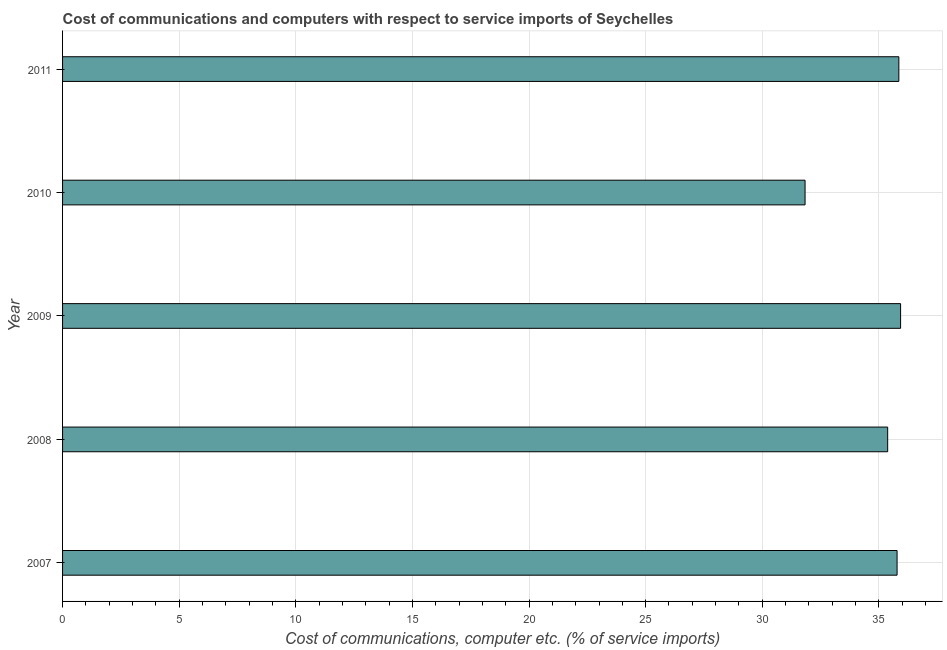Does the graph contain any zero values?
Your answer should be very brief. No. Does the graph contain grids?
Ensure brevity in your answer.  Yes. What is the title of the graph?
Provide a succinct answer. Cost of communications and computers with respect to service imports of Seychelles. What is the label or title of the X-axis?
Offer a terse response. Cost of communications, computer etc. (% of service imports). What is the cost of communications and computer in 2009?
Provide a short and direct response. 35.93. Across all years, what is the maximum cost of communications and computer?
Provide a short and direct response. 35.93. Across all years, what is the minimum cost of communications and computer?
Offer a very short reply. 31.83. In which year was the cost of communications and computer minimum?
Your answer should be compact. 2010. What is the sum of the cost of communications and computer?
Provide a succinct answer. 174.77. What is the difference between the cost of communications and computer in 2009 and 2011?
Provide a succinct answer. 0.07. What is the average cost of communications and computer per year?
Keep it short and to the point. 34.95. What is the median cost of communications and computer?
Ensure brevity in your answer.  35.78. What is the ratio of the cost of communications and computer in 2008 to that in 2009?
Provide a short and direct response. 0.98. Is the cost of communications and computer in 2008 less than that in 2011?
Make the answer very short. Yes. Is the difference between the cost of communications and computer in 2008 and 2010 greater than the difference between any two years?
Offer a very short reply. No. What is the difference between the highest and the second highest cost of communications and computer?
Make the answer very short. 0.07. In how many years, is the cost of communications and computer greater than the average cost of communications and computer taken over all years?
Your answer should be very brief. 4. How many bars are there?
Your response must be concise. 5. Are all the bars in the graph horizontal?
Give a very brief answer. Yes. How many years are there in the graph?
Provide a succinct answer. 5. Are the values on the major ticks of X-axis written in scientific E-notation?
Give a very brief answer. No. What is the Cost of communications, computer etc. (% of service imports) in 2007?
Offer a terse response. 35.78. What is the Cost of communications, computer etc. (% of service imports) in 2008?
Your response must be concise. 35.38. What is the Cost of communications, computer etc. (% of service imports) of 2009?
Keep it short and to the point. 35.93. What is the Cost of communications, computer etc. (% of service imports) of 2010?
Provide a short and direct response. 31.83. What is the Cost of communications, computer etc. (% of service imports) in 2011?
Provide a succinct answer. 35.86. What is the difference between the Cost of communications, computer etc. (% of service imports) in 2007 and 2008?
Give a very brief answer. 0.4. What is the difference between the Cost of communications, computer etc. (% of service imports) in 2007 and 2009?
Offer a terse response. -0.15. What is the difference between the Cost of communications, computer etc. (% of service imports) in 2007 and 2010?
Give a very brief answer. 3.95. What is the difference between the Cost of communications, computer etc. (% of service imports) in 2007 and 2011?
Your answer should be very brief. -0.08. What is the difference between the Cost of communications, computer etc. (% of service imports) in 2008 and 2009?
Provide a short and direct response. -0.55. What is the difference between the Cost of communications, computer etc. (% of service imports) in 2008 and 2010?
Your response must be concise. 3.54. What is the difference between the Cost of communications, computer etc. (% of service imports) in 2008 and 2011?
Keep it short and to the point. -0.48. What is the difference between the Cost of communications, computer etc. (% of service imports) in 2009 and 2010?
Your answer should be compact. 4.1. What is the difference between the Cost of communications, computer etc. (% of service imports) in 2009 and 2011?
Your answer should be very brief. 0.07. What is the difference between the Cost of communications, computer etc. (% of service imports) in 2010 and 2011?
Provide a succinct answer. -4.02. What is the ratio of the Cost of communications, computer etc. (% of service imports) in 2007 to that in 2008?
Offer a very short reply. 1.01. What is the ratio of the Cost of communications, computer etc. (% of service imports) in 2007 to that in 2009?
Give a very brief answer. 1. What is the ratio of the Cost of communications, computer etc. (% of service imports) in 2007 to that in 2010?
Your response must be concise. 1.12. What is the ratio of the Cost of communications, computer etc. (% of service imports) in 2008 to that in 2010?
Your response must be concise. 1.11. What is the ratio of the Cost of communications, computer etc. (% of service imports) in 2008 to that in 2011?
Provide a short and direct response. 0.99. What is the ratio of the Cost of communications, computer etc. (% of service imports) in 2009 to that in 2010?
Your response must be concise. 1.13. What is the ratio of the Cost of communications, computer etc. (% of service imports) in 2009 to that in 2011?
Offer a very short reply. 1. What is the ratio of the Cost of communications, computer etc. (% of service imports) in 2010 to that in 2011?
Offer a very short reply. 0.89. 